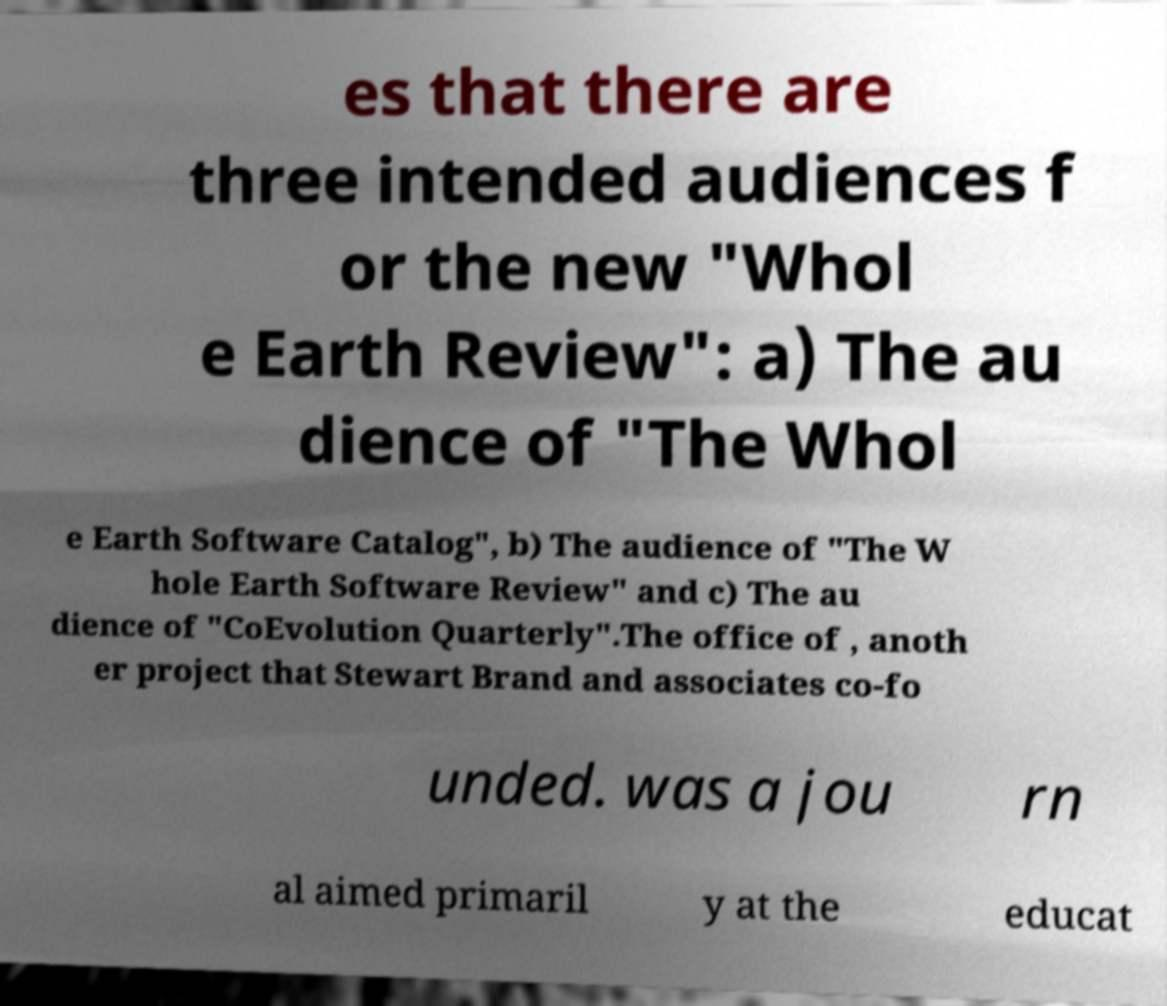What messages or text are displayed in this image? I need them in a readable, typed format. es that there are three intended audiences f or the new "Whol e Earth Review": a) The au dience of "The Whol e Earth Software Catalog", b) The audience of "The W hole Earth Software Review" and c) The au dience of "CoEvolution Quarterly".The office of , anoth er project that Stewart Brand and associates co-fo unded. was a jou rn al aimed primaril y at the educat 